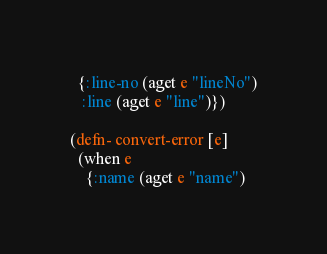<code> <loc_0><loc_0><loc_500><loc_500><_Clojure_>  {:line-no (aget e "lineNo")
   :line (aget e "line")})

(defn- convert-error [e]
  (when e
    {:name (aget e "name")</code> 